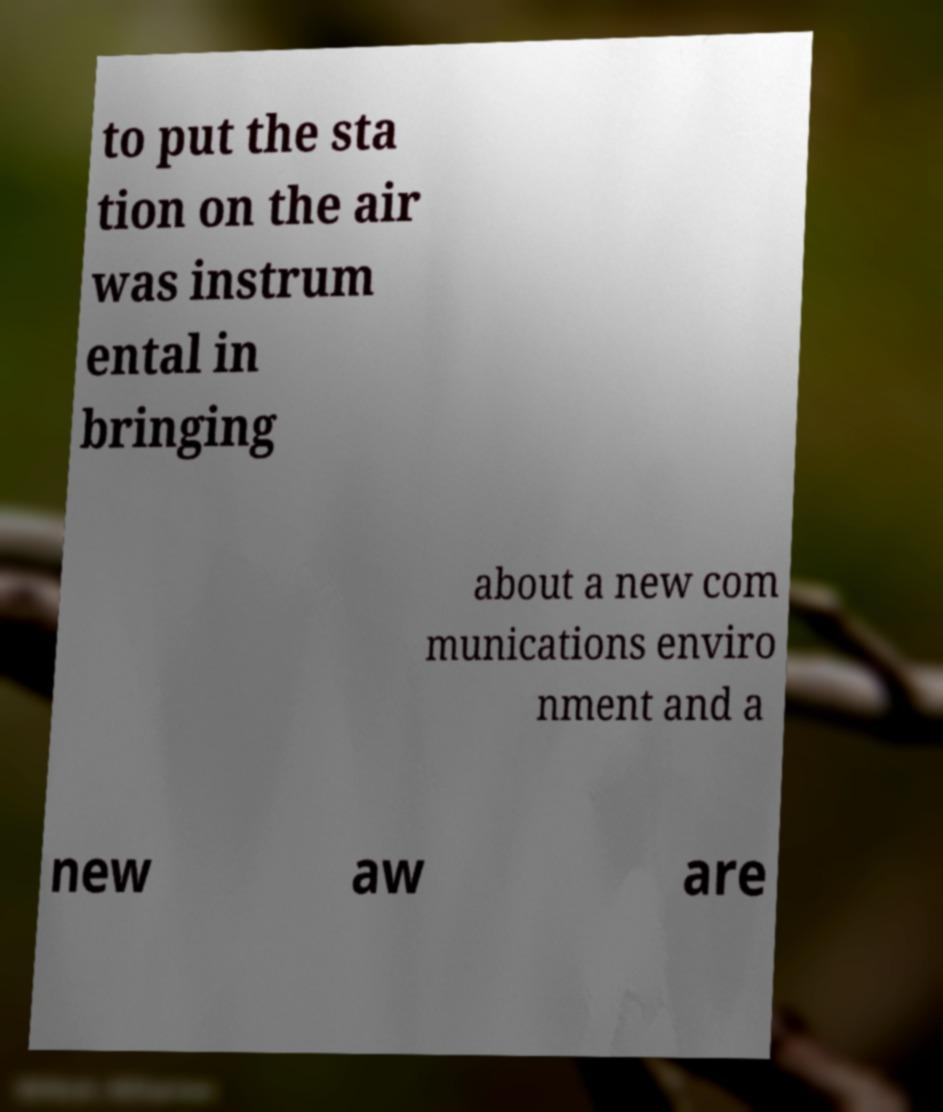I need the written content from this picture converted into text. Can you do that? to put the sta tion on the air was instrum ental in bringing about a new com munications enviro nment and a new aw are 